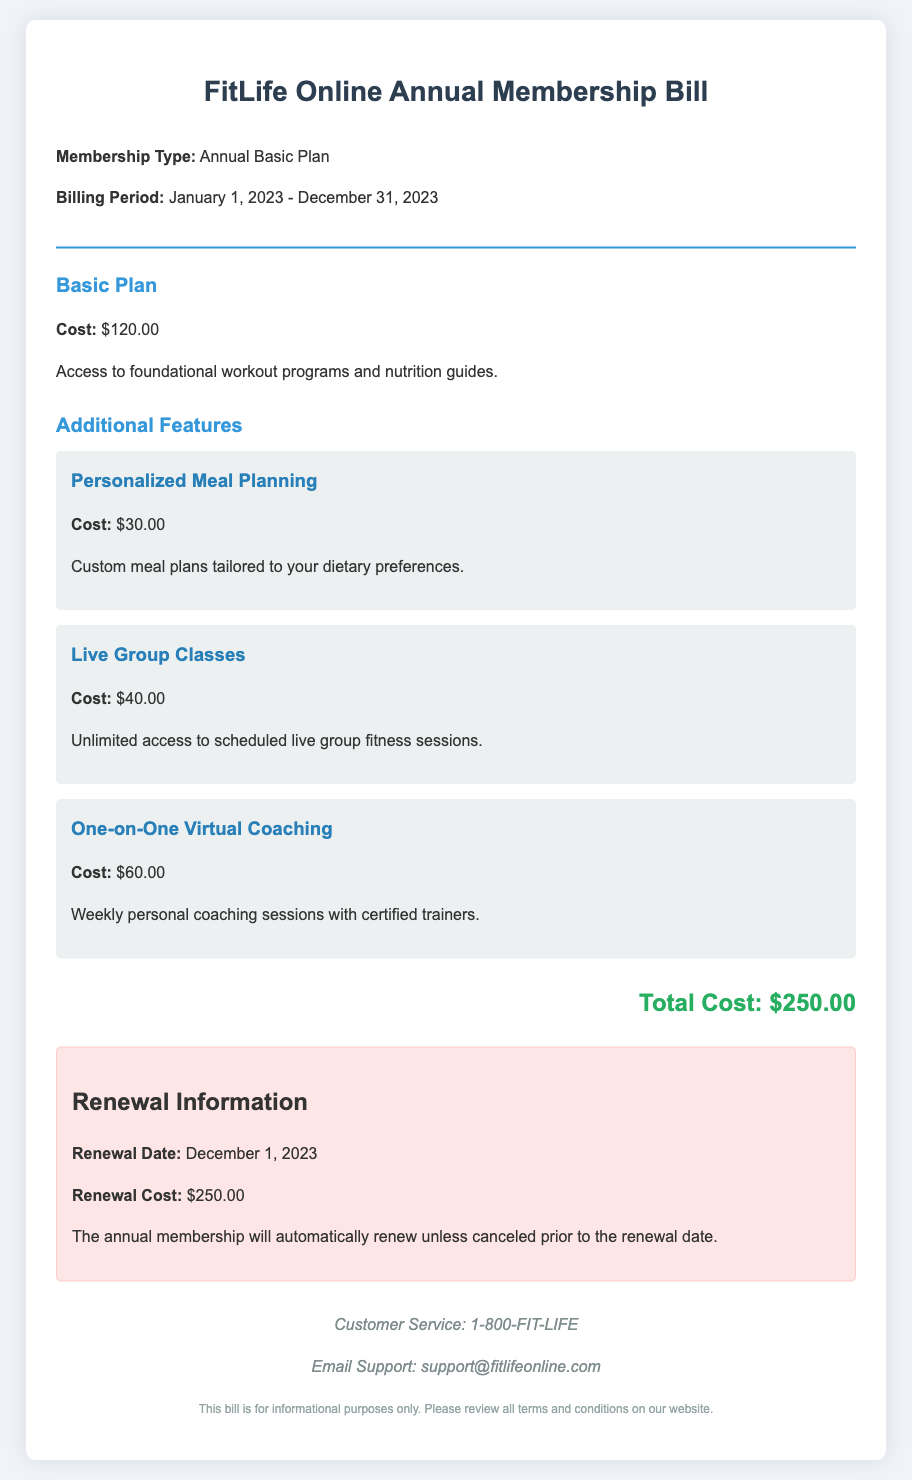What is the membership type? The membership type is specified in the document.
Answer: Annual Basic Plan What is the cost of the Basic Plan? The cost of the Basic Plan is clearly stated in the bill.
Answer: $120.00 What is the total cost of the membership? The total cost combines the Basic Plan and additional features as indicated.
Answer: $250.00 What is the renewal date? The renewal date is mentioned in the renewal information section.
Answer: December 1, 2023 How much does personalized meal planning cost? The cost of personalized meal planning is detailed in the additional features.
Answer: $30.00 What features are included in the basic plan? The document specifies what the basic plan includes in the description.
Answer: Foundational workout programs and nutrition guides What happens if I cancel before the renewal date? The document indicates the procedure regarding cancellation prior to renewal.
Answer: Membership will not renew How many one-on-one virtual coaching sessions are included? The document specifically mentions the frequency of the coaching sessions.
Answer: Weekly What is the contact number for customer service? The customer service number is provided in the contact info section.
Answer: 1-800-FIT-LIFE 